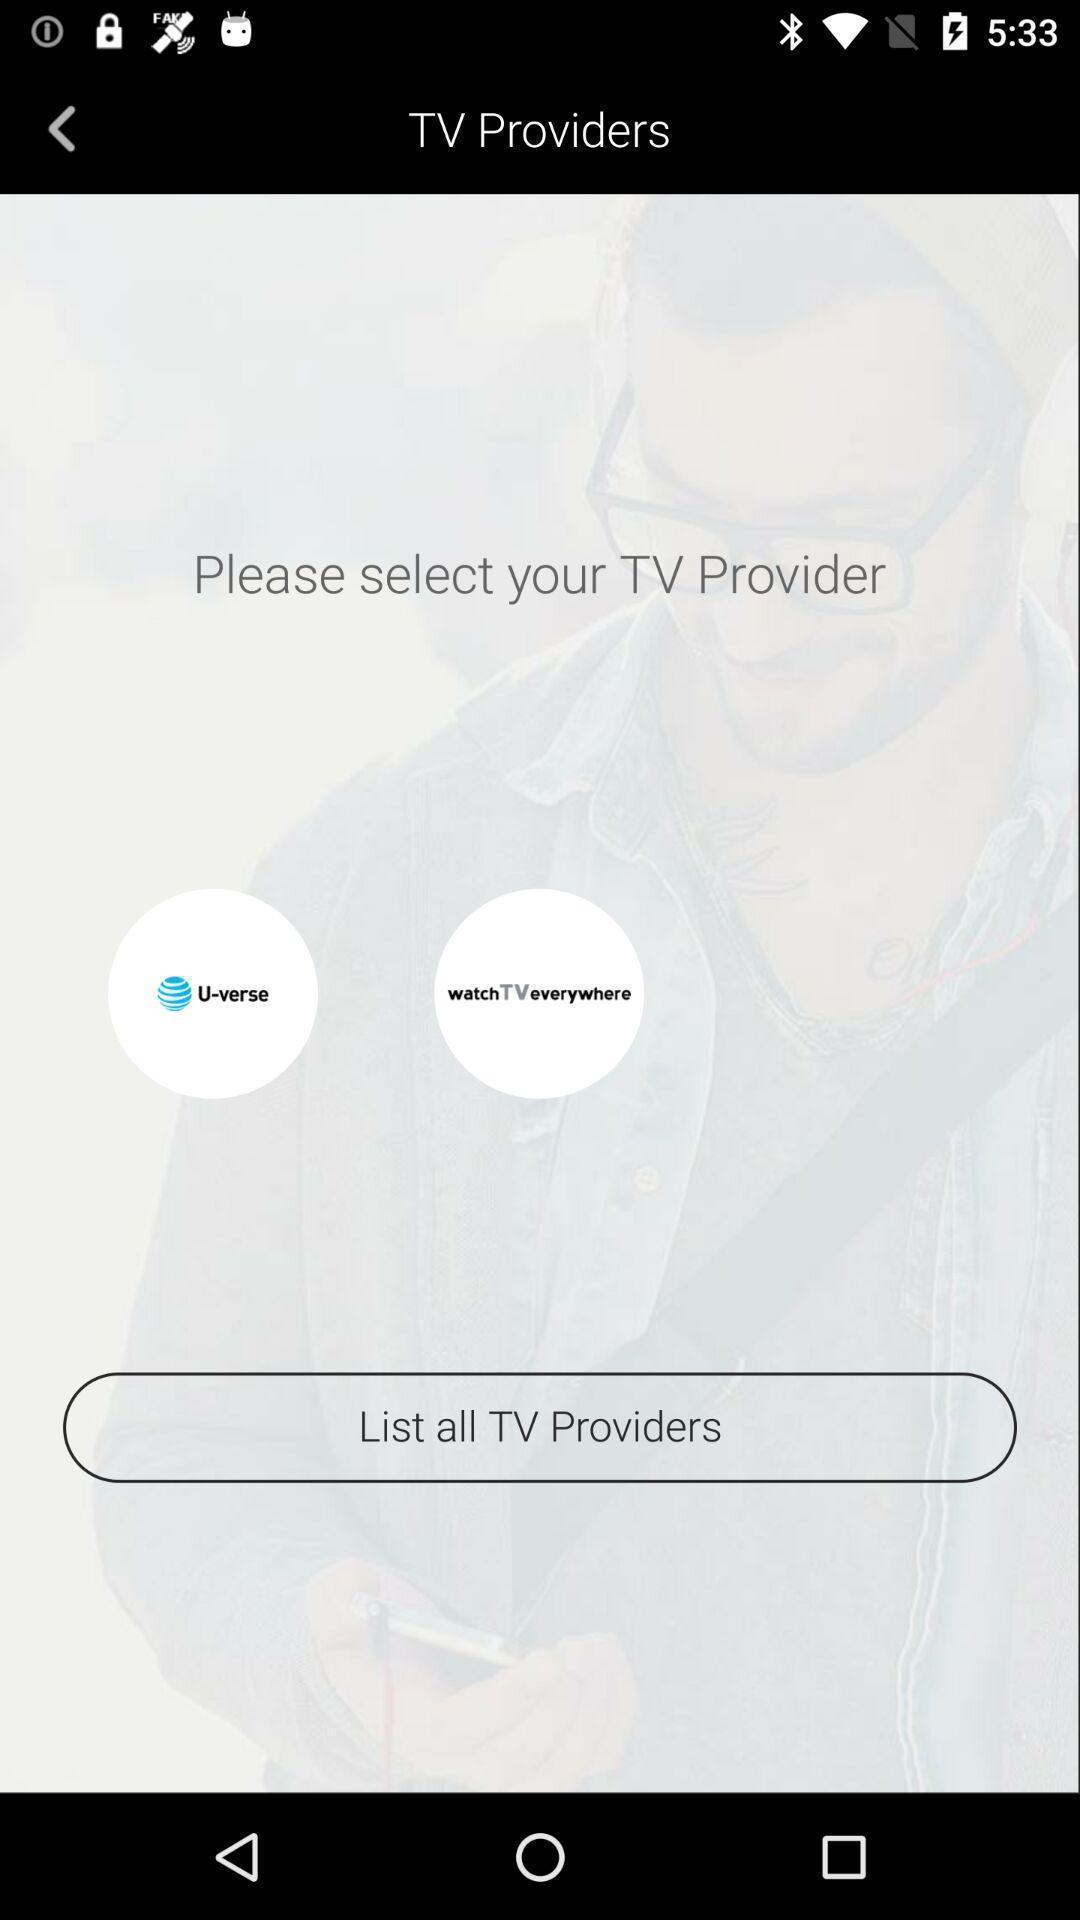Provide a description of this screenshot. Screen shows list all tv providers in a entertainment app. 